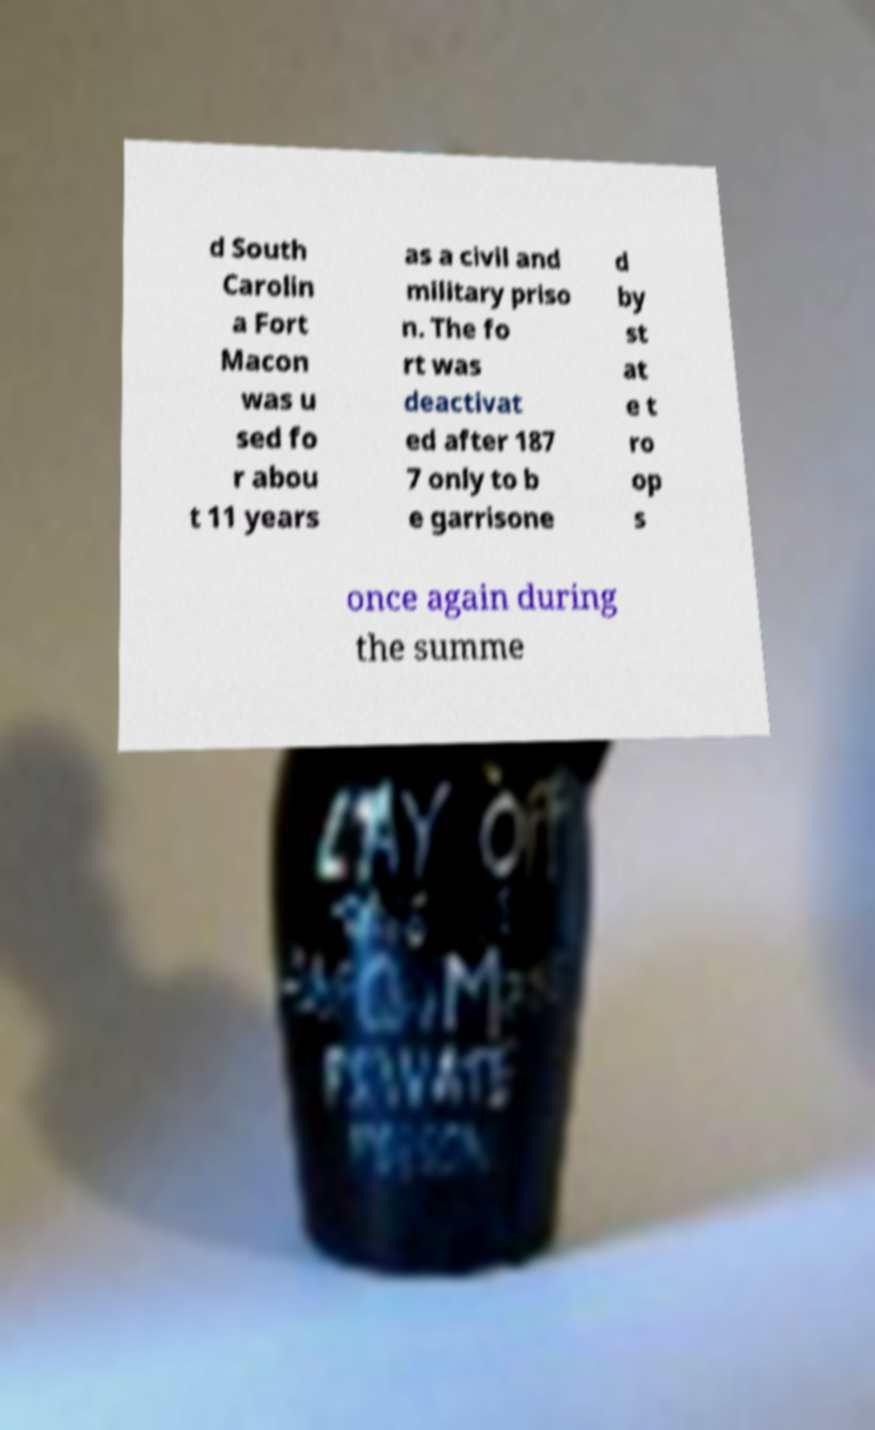Could you extract and type out the text from this image? d South Carolin a Fort Macon was u sed fo r abou t 11 years as a civil and military priso n. The fo rt was deactivat ed after 187 7 only to b e garrisone d by st at e t ro op s once again during the summe 